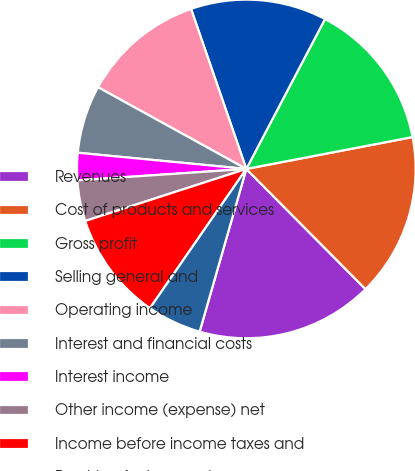Convert chart. <chart><loc_0><loc_0><loc_500><loc_500><pie_chart><fcel>Revenues<fcel>Cost of products and services<fcel>Gross profit<fcel>Selling general and<fcel>Operating income<fcel>Interest and financial costs<fcel>Interest income<fcel>Other income (expense) net<fcel>Income before income taxes and<fcel>Provision for income taxes<nl><fcel>16.88%<fcel>15.58%<fcel>14.29%<fcel>12.99%<fcel>11.69%<fcel>6.49%<fcel>2.6%<fcel>3.9%<fcel>10.39%<fcel>5.19%<nl></chart> 